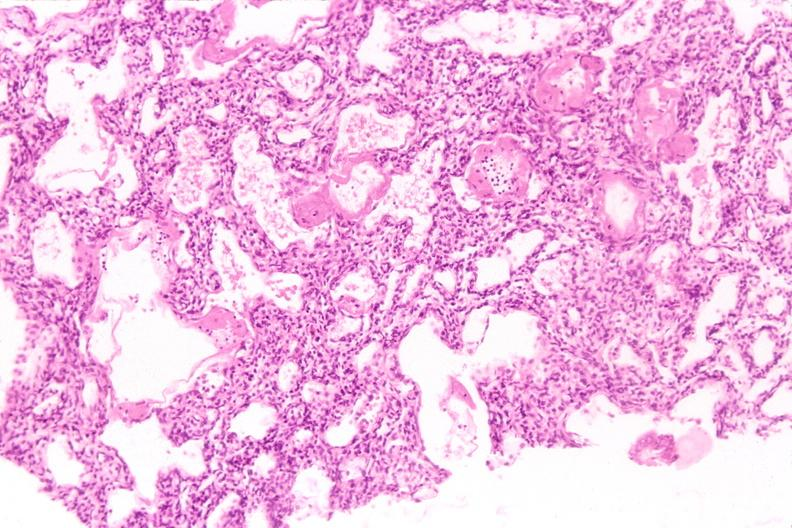what is present?
Answer the question using a single word or phrase. Respiratory 